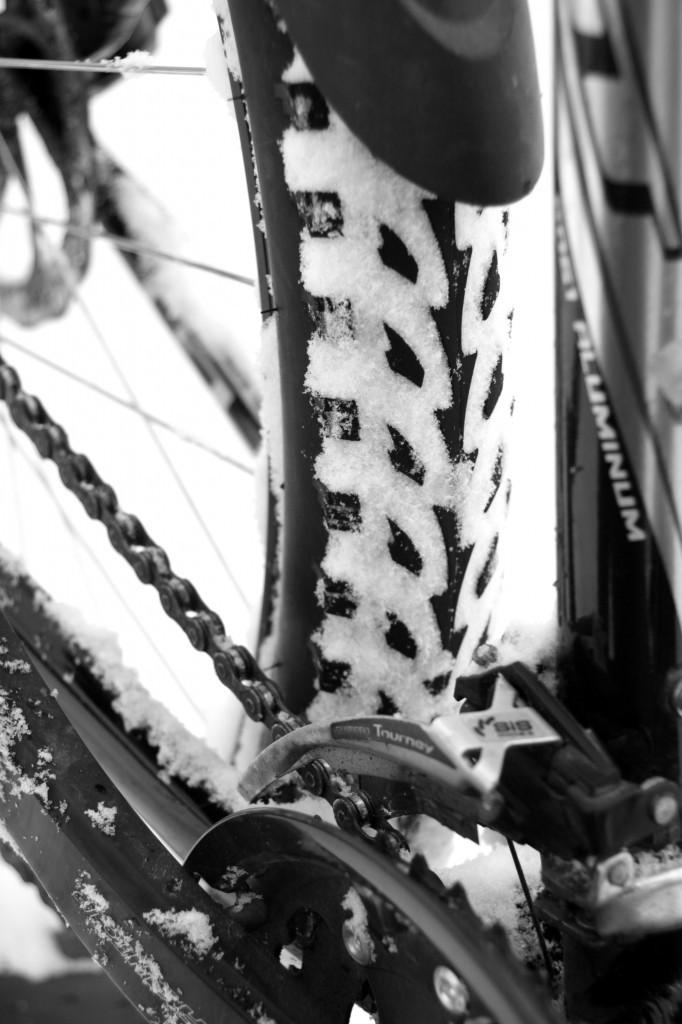What part of a cycle can be seen in the image? The back wheel of a cycle is visible in the image. What is connected to the back wheel? There is a chain associated with the back wheel. What feature is present near the back wheel to protect from dirt and water? A mudguard is present near the back wheel. How many pears can be seen hanging from the chain in the image? There are no pears present in the image; it features a back wheel of a cycle with a chain and a mudguard. 